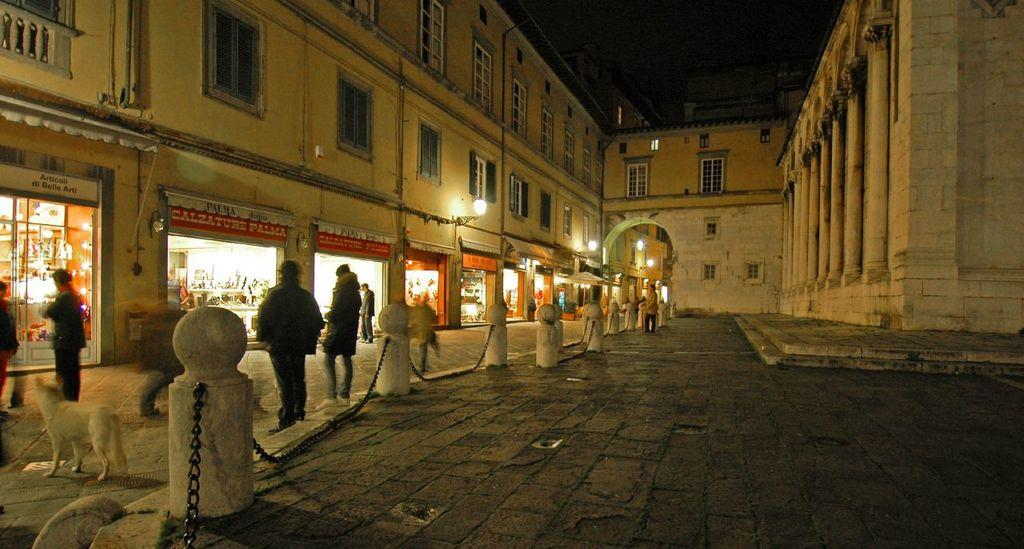<image>
Give a short and clear explanation of the subsequent image. people are doing window shopping at night at Palma 